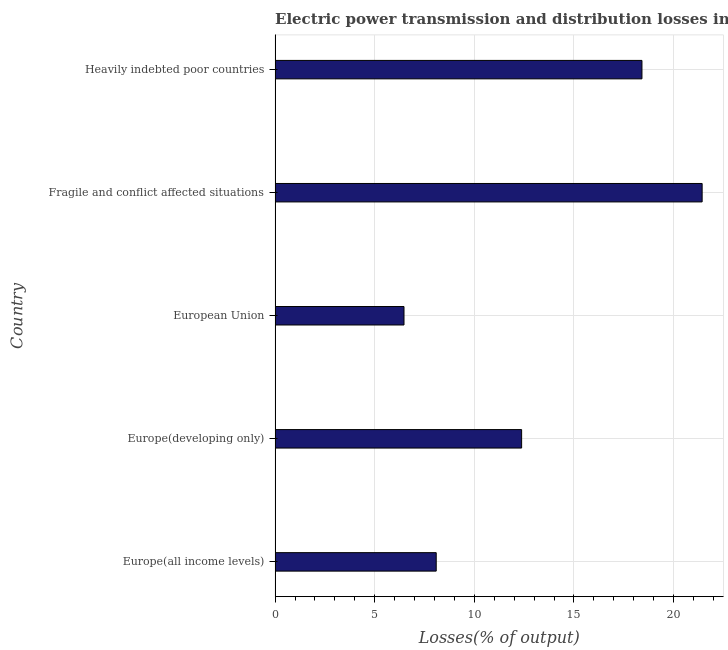Does the graph contain grids?
Provide a succinct answer. Yes. What is the title of the graph?
Your answer should be very brief. Electric power transmission and distribution losses in the year 2012. What is the label or title of the X-axis?
Your answer should be compact. Losses(% of output). What is the label or title of the Y-axis?
Your response must be concise. Country. What is the electric power transmission and distribution losses in Europe(developing only)?
Keep it short and to the point. 12.37. Across all countries, what is the maximum electric power transmission and distribution losses?
Provide a succinct answer. 21.43. Across all countries, what is the minimum electric power transmission and distribution losses?
Your response must be concise. 6.47. In which country was the electric power transmission and distribution losses maximum?
Your response must be concise. Fragile and conflict affected situations. In which country was the electric power transmission and distribution losses minimum?
Your answer should be very brief. European Union. What is the sum of the electric power transmission and distribution losses?
Provide a succinct answer. 66.78. What is the difference between the electric power transmission and distribution losses in Fragile and conflict affected situations and Heavily indebted poor countries?
Your response must be concise. 3.02. What is the average electric power transmission and distribution losses per country?
Ensure brevity in your answer.  13.36. What is the median electric power transmission and distribution losses?
Make the answer very short. 12.37. In how many countries, is the electric power transmission and distribution losses greater than 10 %?
Keep it short and to the point. 3. What is the ratio of the electric power transmission and distribution losses in Europe(developing only) to that in Heavily indebted poor countries?
Your answer should be compact. 0.67. Is the electric power transmission and distribution losses in Europe(developing only) less than that in Heavily indebted poor countries?
Offer a very short reply. Yes. Is the difference between the electric power transmission and distribution losses in Europe(developing only) and European Union greater than the difference between any two countries?
Give a very brief answer. No. What is the difference between the highest and the second highest electric power transmission and distribution losses?
Provide a short and direct response. 3.02. Is the sum of the electric power transmission and distribution losses in Europe(developing only) and Heavily indebted poor countries greater than the maximum electric power transmission and distribution losses across all countries?
Provide a short and direct response. Yes. What is the difference between the highest and the lowest electric power transmission and distribution losses?
Your answer should be compact. 14.96. In how many countries, is the electric power transmission and distribution losses greater than the average electric power transmission and distribution losses taken over all countries?
Provide a succinct answer. 2. How many bars are there?
Provide a short and direct response. 5. Are all the bars in the graph horizontal?
Make the answer very short. Yes. What is the Losses(% of output) of Europe(all income levels)?
Ensure brevity in your answer.  8.09. What is the Losses(% of output) of Europe(developing only)?
Your answer should be very brief. 12.37. What is the Losses(% of output) of European Union?
Provide a short and direct response. 6.47. What is the Losses(% of output) of Fragile and conflict affected situations?
Ensure brevity in your answer.  21.43. What is the Losses(% of output) in Heavily indebted poor countries?
Keep it short and to the point. 18.41. What is the difference between the Losses(% of output) in Europe(all income levels) and Europe(developing only)?
Ensure brevity in your answer.  -4.29. What is the difference between the Losses(% of output) in Europe(all income levels) and European Union?
Your response must be concise. 1.62. What is the difference between the Losses(% of output) in Europe(all income levels) and Fragile and conflict affected situations?
Ensure brevity in your answer.  -13.35. What is the difference between the Losses(% of output) in Europe(all income levels) and Heavily indebted poor countries?
Your answer should be compact. -10.33. What is the difference between the Losses(% of output) in Europe(developing only) and European Union?
Give a very brief answer. 5.9. What is the difference between the Losses(% of output) in Europe(developing only) and Fragile and conflict affected situations?
Your answer should be compact. -9.06. What is the difference between the Losses(% of output) in Europe(developing only) and Heavily indebted poor countries?
Offer a very short reply. -6.04. What is the difference between the Losses(% of output) in European Union and Fragile and conflict affected situations?
Your answer should be compact. -14.96. What is the difference between the Losses(% of output) in European Union and Heavily indebted poor countries?
Your answer should be compact. -11.94. What is the difference between the Losses(% of output) in Fragile and conflict affected situations and Heavily indebted poor countries?
Keep it short and to the point. 3.02. What is the ratio of the Losses(% of output) in Europe(all income levels) to that in Europe(developing only)?
Provide a short and direct response. 0.65. What is the ratio of the Losses(% of output) in Europe(all income levels) to that in European Union?
Make the answer very short. 1.25. What is the ratio of the Losses(% of output) in Europe(all income levels) to that in Fragile and conflict affected situations?
Provide a short and direct response. 0.38. What is the ratio of the Losses(% of output) in Europe(all income levels) to that in Heavily indebted poor countries?
Provide a short and direct response. 0.44. What is the ratio of the Losses(% of output) in Europe(developing only) to that in European Union?
Your answer should be compact. 1.91. What is the ratio of the Losses(% of output) in Europe(developing only) to that in Fragile and conflict affected situations?
Offer a terse response. 0.58. What is the ratio of the Losses(% of output) in Europe(developing only) to that in Heavily indebted poor countries?
Offer a terse response. 0.67. What is the ratio of the Losses(% of output) in European Union to that in Fragile and conflict affected situations?
Give a very brief answer. 0.3. What is the ratio of the Losses(% of output) in European Union to that in Heavily indebted poor countries?
Your response must be concise. 0.35. What is the ratio of the Losses(% of output) in Fragile and conflict affected situations to that in Heavily indebted poor countries?
Your response must be concise. 1.16. 